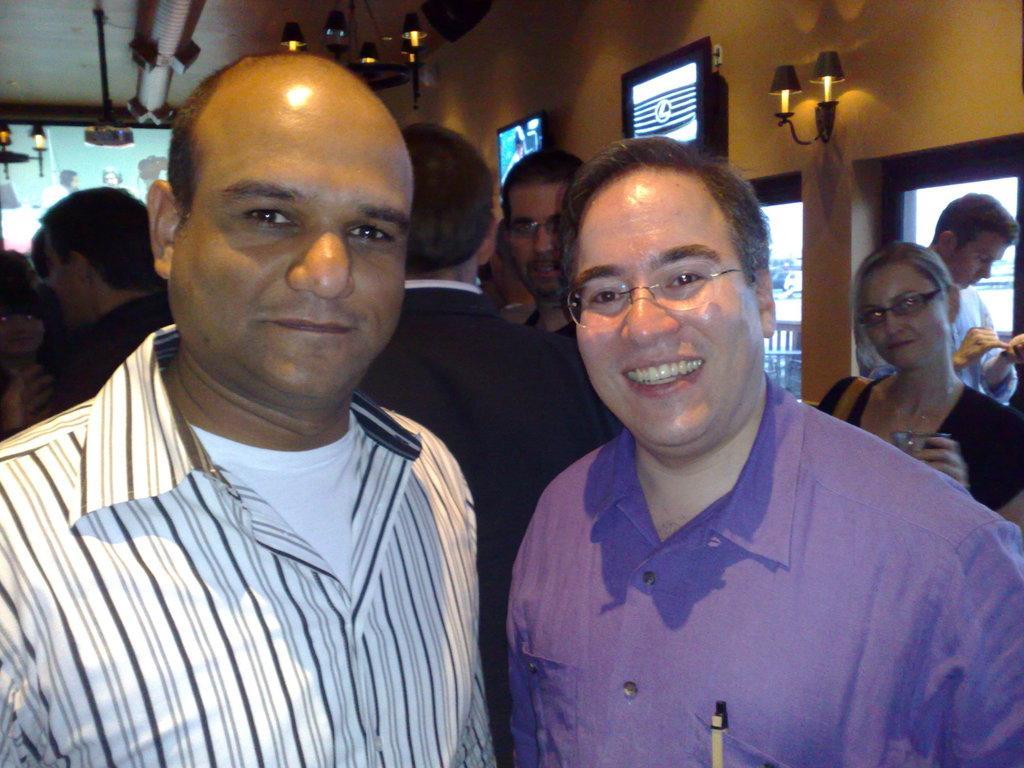Can you describe this image briefly? In this picture there are men in the center of the image and there are other people in the background area of the image and there are lamps, screens, and windows in the background area of the image. 